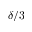<formula> <loc_0><loc_0><loc_500><loc_500>\delta / 3</formula> 